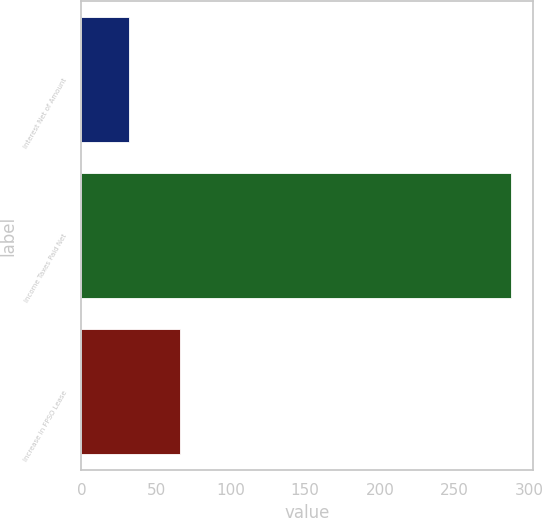Convert chart. <chart><loc_0><loc_0><loc_500><loc_500><bar_chart><fcel>Interest Net of Amount<fcel>Income Taxes Paid Net<fcel>Increase in FPSO Lease<nl><fcel>32<fcel>288<fcel>66<nl></chart> 